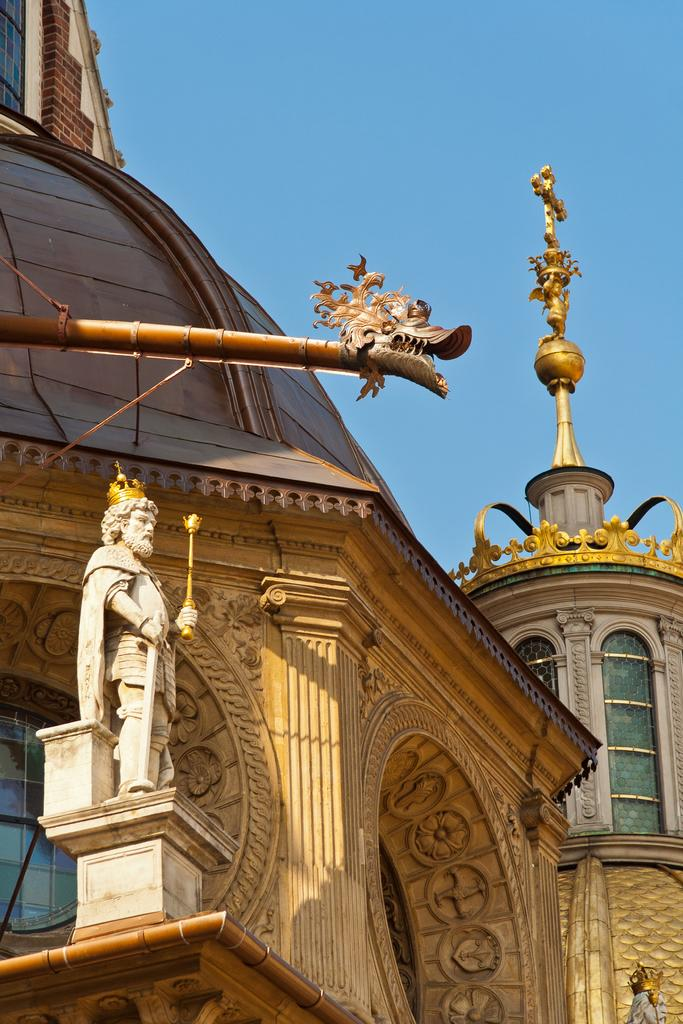What type of structures can be seen in the image? There are buildings in the image. What feature is common among the buildings? There are windows in the image. What additional object can be found in the image? There is a statue in the image. What is visible in the background of the image? The sky is visible in the image. How many thumbs can be seen on the statue in the image? There are no thumbs visible on the statue in the image, as statues typically do not have body parts like humans. 